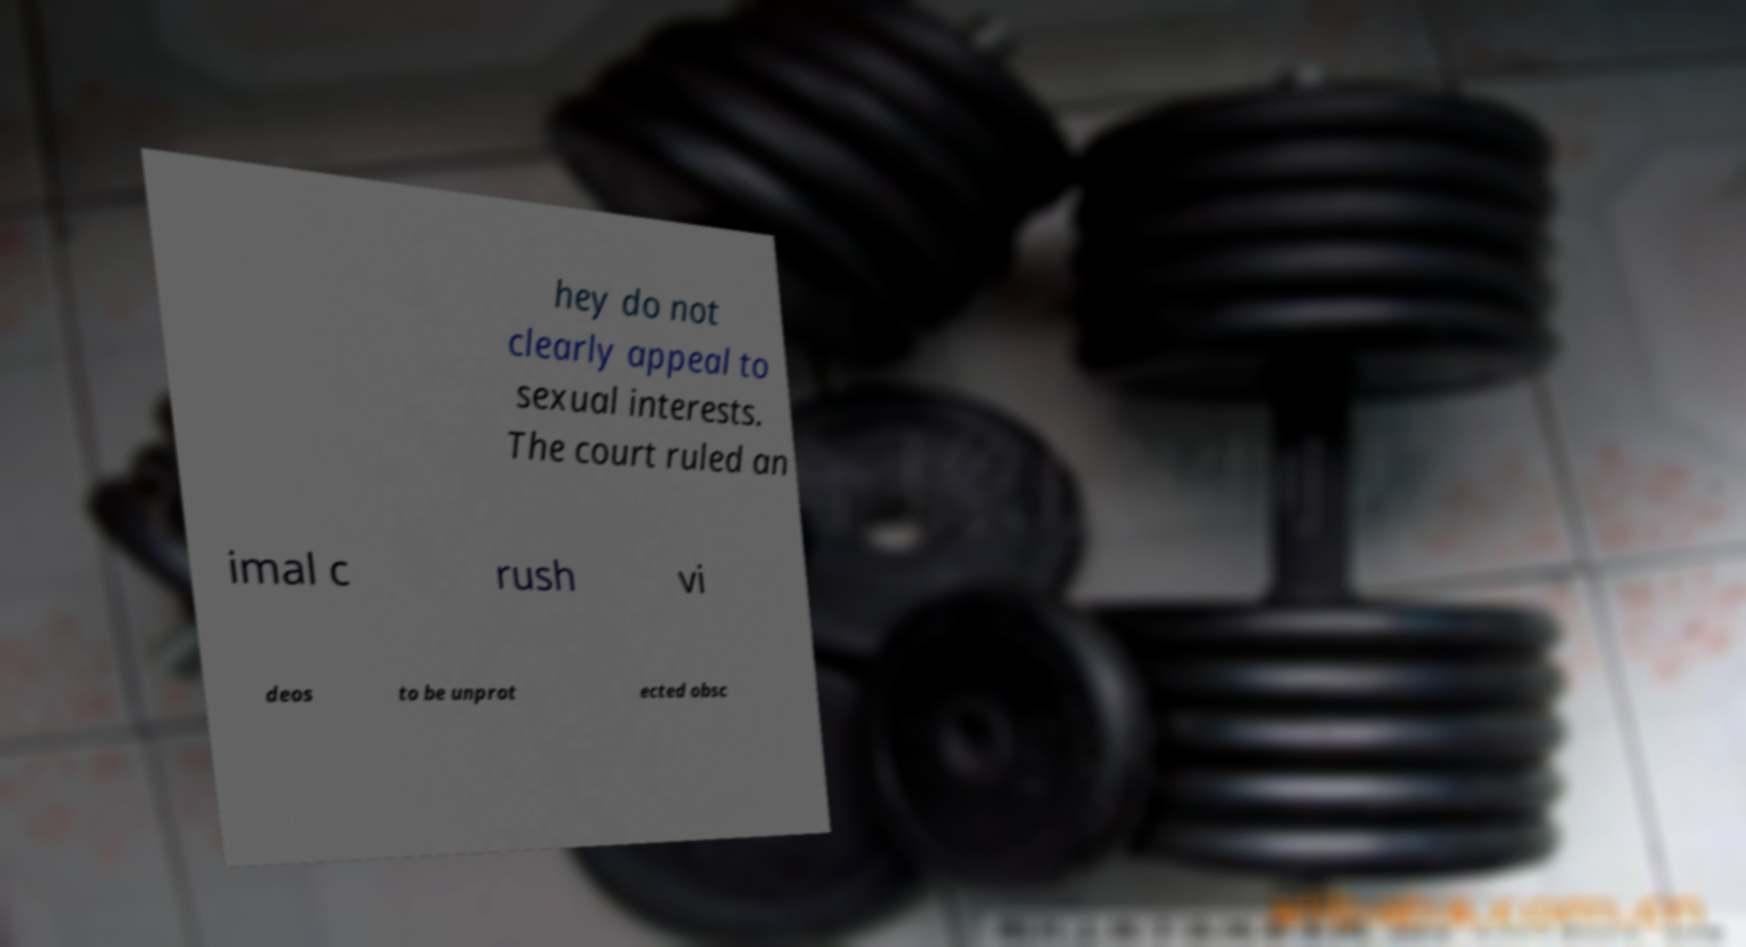Please read and relay the text visible in this image. What does it say? hey do not clearly appeal to sexual interests. The court ruled an imal c rush vi deos to be unprot ected obsc 